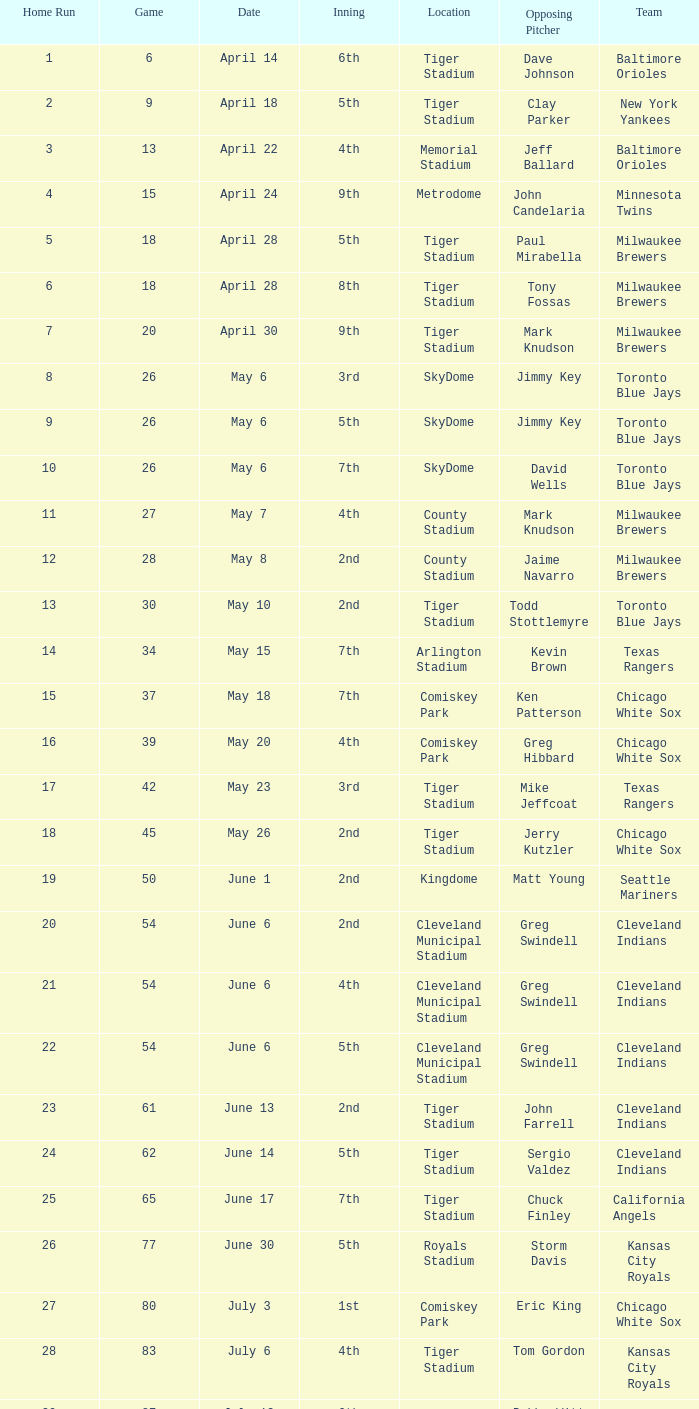On which date was the game held at comiskey park that included a 4th inning? May 20. 